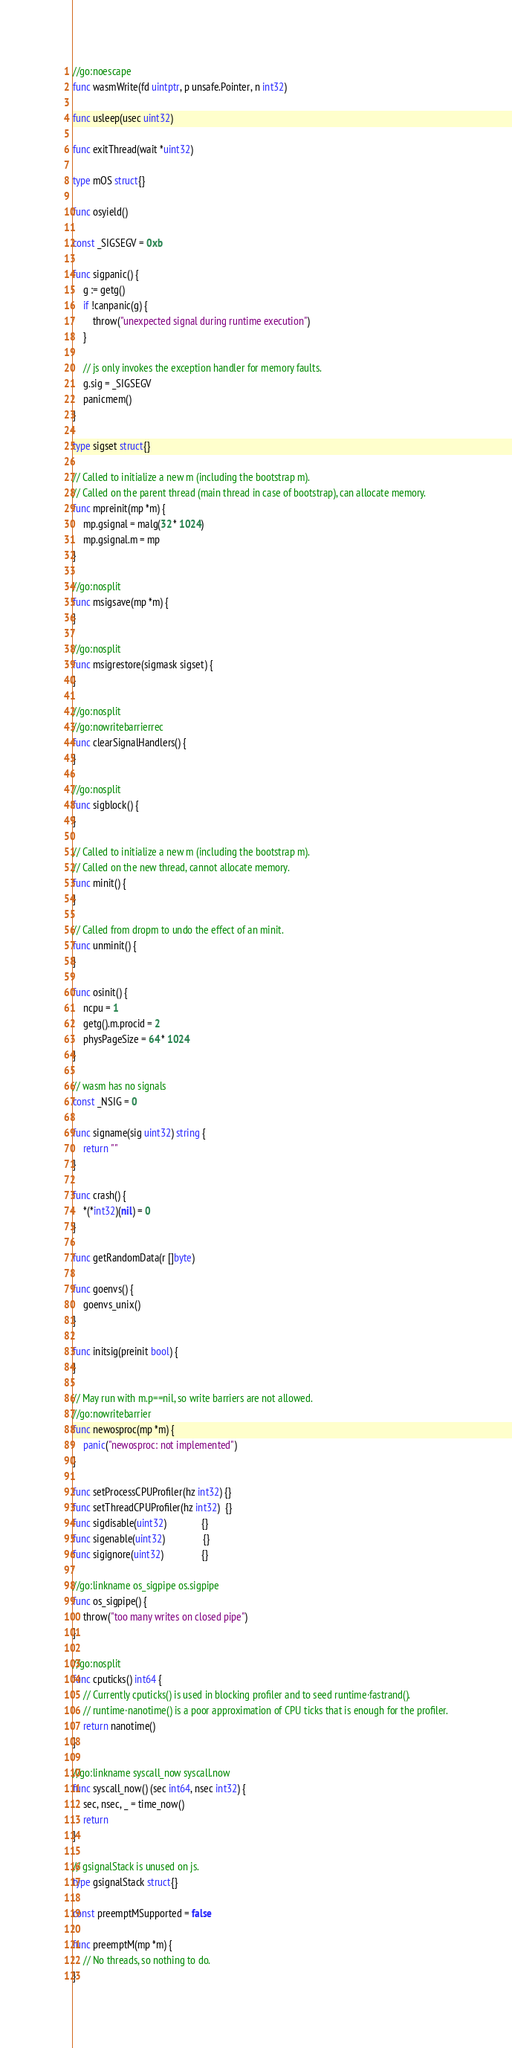Convert code to text. <code><loc_0><loc_0><loc_500><loc_500><_Go_>
//go:noescape
func wasmWrite(fd uintptr, p unsafe.Pointer, n int32)

func usleep(usec uint32)

func exitThread(wait *uint32)

type mOS struct{}

func osyield()

const _SIGSEGV = 0xb

func sigpanic() {
	g := getg()
	if !canpanic(g) {
		throw("unexpected signal during runtime execution")
	}

	// js only invokes the exception handler for memory faults.
	g.sig = _SIGSEGV
	panicmem()
}

type sigset struct{}

// Called to initialize a new m (including the bootstrap m).
// Called on the parent thread (main thread in case of bootstrap), can allocate memory.
func mpreinit(mp *m) {
	mp.gsignal = malg(32 * 1024)
	mp.gsignal.m = mp
}

//go:nosplit
func msigsave(mp *m) {
}

//go:nosplit
func msigrestore(sigmask sigset) {
}

//go:nosplit
//go:nowritebarrierrec
func clearSignalHandlers() {
}

//go:nosplit
func sigblock() {
}

// Called to initialize a new m (including the bootstrap m).
// Called on the new thread, cannot allocate memory.
func minit() {
}

// Called from dropm to undo the effect of an minit.
func unminit() {
}

func osinit() {
	ncpu = 1
	getg().m.procid = 2
	physPageSize = 64 * 1024
}

// wasm has no signals
const _NSIG = 0

func signame(sig uint32) string {
	return ""
}

func crash() {
	*(*int32)(nil) = 0
}

func getRandomData(r []byte)

func goenvs() {
	goenvs_unix()
}

func initsig(preinit bool) {
}

// May run with m.p==nil, so write barriers are not allowed.
//go:nowritebarrier
func newosproc(mp *m) {
	panic("newosproc: not implemented")
}

func setProcessCPUProfiler(hz int32) {}
func setThreadCPUProfiler(hz int32)  {}
func sigdisable(uint32)              {}
func sigenable(uint32)               {}
func sigignore(uint32)               {}

//go:linkname os_sigpipe os.sigpipe
func os_sigpipe() {
	throw("too many writes on closed pipe")
}

//go:nosplit
func cputicks() int64 {
	// Currently cputicks() is used in blocking profiler and to seed runtime·fastrand().
	// runtime·nanotime() is a poor approximation of CPU ticks that is enough for the profiler.
	return nanotime()
}

//go:linkname syscall_now syscall.now
func syscall_now() (sec int64, nsec int32) {
	sec, nsec, _ = time_now()
	return
}

// gsignalStack is unused on js.
type gsignalStack struct{}

const preemptMSupported = false

func preemptM(mp *m) {
	// No threads, so nothing to do.
}
</code> 